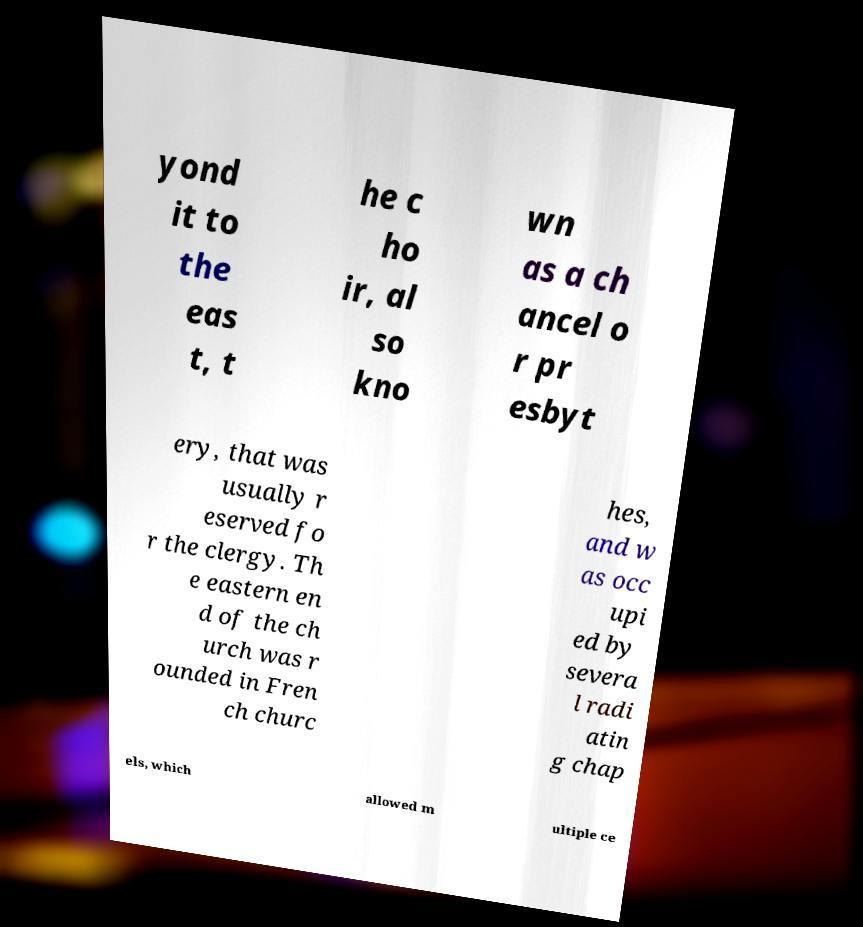I need the written content from this picture converted into text. Can you do that? yond it to the eas t, t he c ho ir, al so kno wn as a ch ancel o r pr esbyt ery, that was usually r eserved fo r the clergy. Th e eastern en d of the ch urch was r ounded in Fren ch churc hes, and w as occ upi ed by severa l radi atin g chap els, which allowed m ultiple ce 